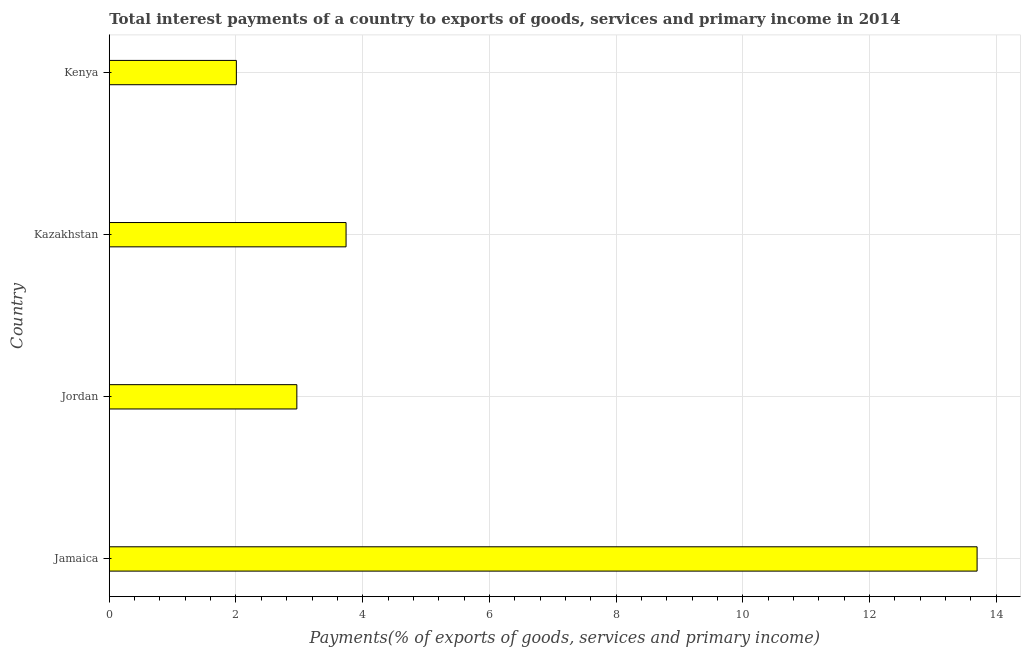What is the title of the graph?
Provide a short and direct response. Total interest payments of a country to exports of goods, services and primary income in 2014. What is the label or title of the X-axis?
Offer a very short reply. Payments(% of exports of goods, services and primary income). What is the label or title of the Y-axis?
Provide a succinct answer. Country. What is the total interest payments on external debt in Jamaica?
Your response must be concise. 13.7. Across all countries, what is the maximum total interest payments on external debt?
Provide a succinct answer. 13.7. Across all countries, what is the minimum total interest payments on external debt?
Keep it short and to the point. 2.01. In which country was the total interest payments on external debt maximum?
Provide a short and direct response. Jamaica. In which country was the total interest payments on external debt minimum?
Keep it short and to the point. Kenya. What is the sum of the total interest payments on external debt?
Provide a succinct answer. 22.4. What is the difference between the total interest payments on external debt in Jordan and Kenya?
Provide a short and direct response. 0.95. What is the average total interest payments on external debt per country?
Give a very brief answer. 5.6. What is the median total interest payments on external debt?
Your answer should be compact. 3.35. What is the ratio of the total interest payments on external debt in Jamaica to that in Jordan?
Give a very brief answer. 4.63. What is the difference between the highest and the second highest total interest payments on external debt?
Offer a terse response. 9.96. Is the sum of the total interest payments on external debt in Jamaica and Kenya greater than the maximum total interest payments on external debt across all countries?
Provide a succinct answer. Yes. What is the difference between the highest and the lowest total interest payments on external debt?
Keep it short and to the point. 11.69. In how many countries, is the total interest payments on external debt greater than the average total interest payments on external debt taken over all countries?
Give a very brief answer. 1. How many bars are there?
Your response must be concise. 4. Are all the bars in the graph horizontal?
Your answer should be very brief. Yes. How many countries are there in the graph?
Make the answer very short. 4. What is the difference between two consecutive major ticks on the X-axis?
Your response must be concise. 2. Are the values on the major ticks of X-axis written in scientific E-notation?
Your response must be concise. No. What is the Payments(% of exports of goods, services and primary income) of Jamaica?
Give a very brief answer. 13.7. What is the Payments(% of exports of goods, services and primary income) of Jordan?
Offer a very short reply. 2.96. What is the Payments(% of exports of goods, services and primary income) in Kazakhstan?
Your answer should be very brief. 3.74. What is the Payments(% of exports of goods, services and primary income) of Kenya?
Your answer should be compact. 2.01. What is the difference between the Payments(% of exports of goods, services and primary income) in Jamaica and Jordan?
Provide a succinct answer. 10.74. What is the difference between the Payments(% of exports of goods, services and primary income) in Jamaica and Kazakhstan?
Provide a succinct answer. 9.96. What is the difference between the Payments(% of exports of goods, services and primary income) in Jamaica and Kenya?
Your answer should be very brief. 11.69. What is the difference between the Payments(% of exports of goods, services and primary income) in Jordan and Kazakhstan?
Ensure brevity in your answer.  -0.78. What is the difference between the Payments(% of exports of goods, services and primary income) in Jordan and Kenya?
Offer a very short reply. 0.95. What is the difference between the Payments(% of exports of goods, services and primary income) in Kazakhstan and Kenya?
Ensure brevity in your answer.  1.73. What is the ratio of the Payments(% of exports of goods, services and primary income) in Jamaica to that in Jordan?
Your answer should be compact. 4.63. What is the ratio of the Payments(% of exports of goods, services and primary income) in Jamaica to that in Kazakhstan?
Offer a very short reply. 3.67. What is the ratio of the Payments(% of exports of goods, services and primary income) in Jamaica to that in Kenya?
Offer a very short reply. 6.83. What is the ratio of the Payments(% of exports of goods, services and primary income) in Jordan to that in Kazakhstan?
Offer a terse response. 0.79. What is the ratio of the Payments(% of exports of goods, services and primary income) in Jordan to that in Kenya?
Ensure brevity in your answer.  1.48. What is the ratio of the Payments(% of exports of goods, services and primary income) in Kazakhstan to that in Kenya?
Your answer should be very brief. 1.86. 